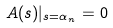<formula> <loc_0><loc_0><loc_500><loc_500>A ( s ) | _ { s = \alpha _ { n } } = 0</formula> 